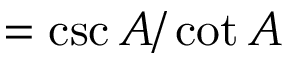<formula> <loc_0><loc_0><loc_500><loc_500>= { \csc A / \cot A }</formula> 